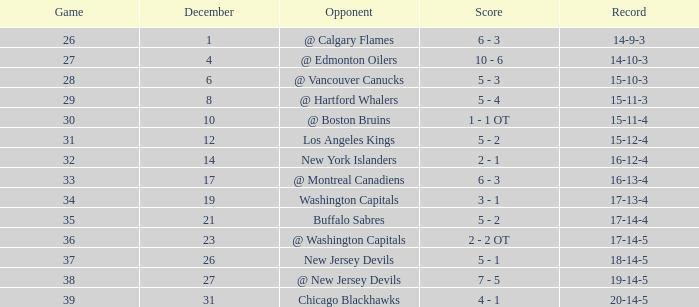What record was achieved by a game over 34 and a december less than 23? 17-14-4. 